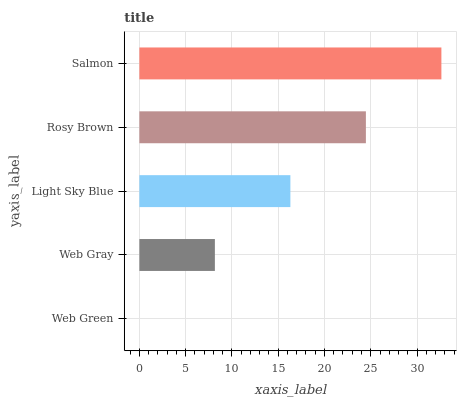Is Web Green the minimum?
Answer yes or no. Yes. Is Salmon the maximum?
Answer yes or no. Yes. Is Web Gray the minimum?
Answer yes or no. No. Is Web Gray the maximum?
Answer yes or no. No. Is Web Gray greater than Web Green?
Answer yes or no. Yes. Is Web Green less than Web Gray?
Answer yes or no. Yes. Is Web Green greater than Web Gray?
Answer yes or no. No. Is Web Gray less than Web Green?
Answer yes or no. No. Is Light Sky Blue the high median?
Answer yes or no. Yes. Is Light Sky Blue the low median?
Answer yes or no. Yes. Is Rosy Brown the high median?
Answer yes or no. No. Is Web Green the low median?
Answer yes or no. No. 